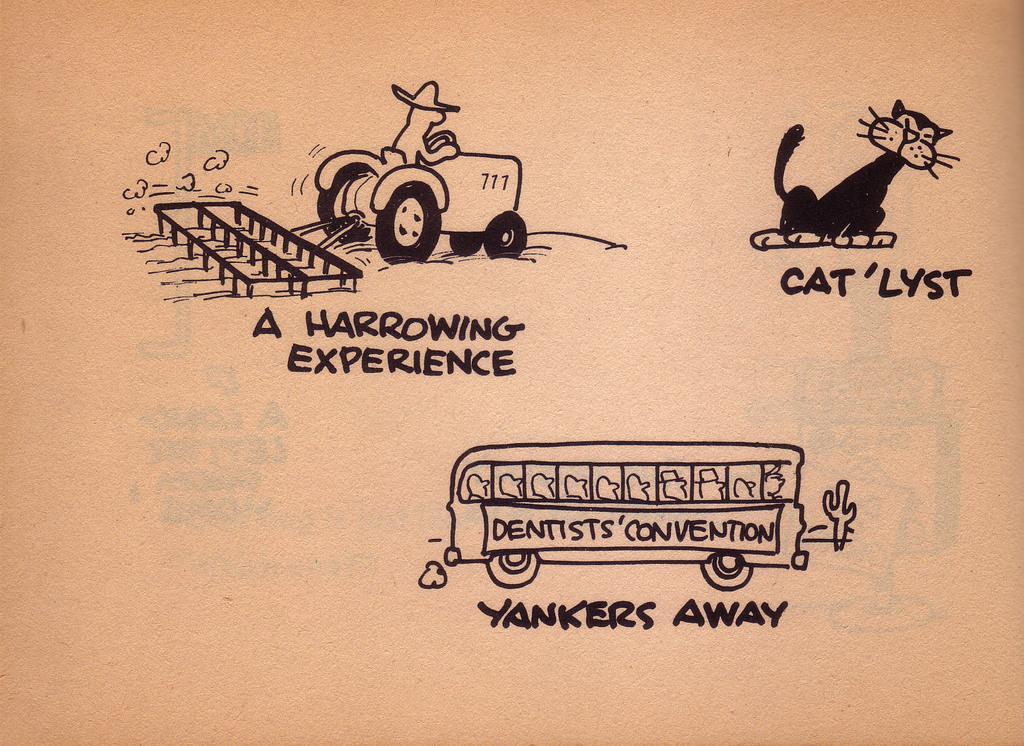In one or two sentences, can you explain what this image depicts? In this image I can see a paper, in the paper I can see few cartoon toys. In front I can see a bus and something written on the paper. 